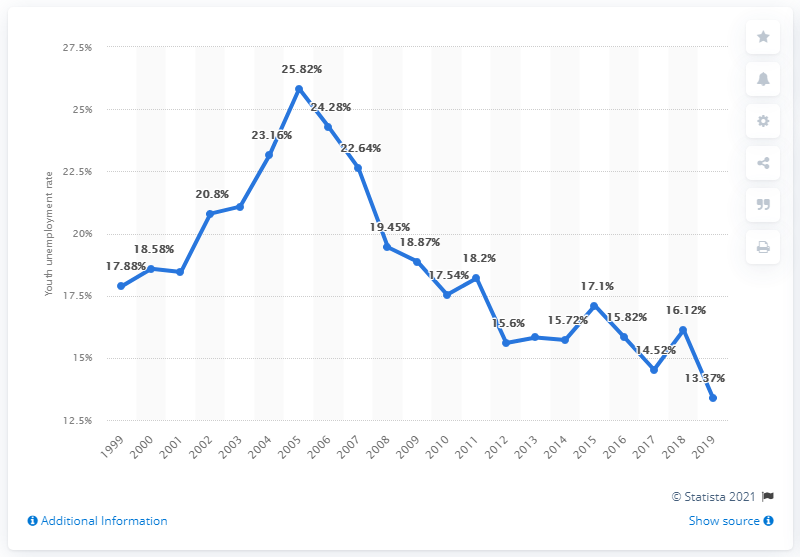List a handful of essential elements in this visual. In 2019, the youth unemployment rate in Indonesia was 13.37%. 